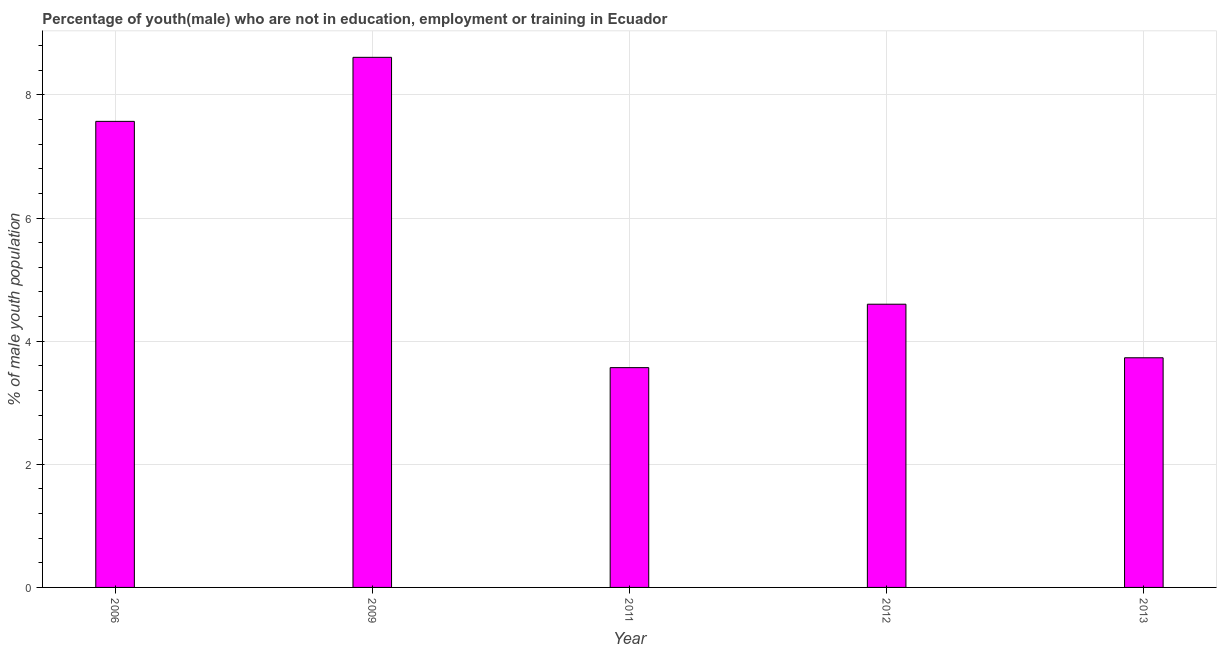Does the graph contain any zero values?
Make the answer very short. No. What is the title of the graph?
Keep it short and to the point. Percentage of youth(male) who are not in education, employment or training in Ecuador. What is the label or title of the X-axis?
Your answer should be compact. Year. What is the label or title of the Y-axis?
Offer a terse response. % of male youth population. What is the unemployed male youth population in 2012?
Your answer should be very brief. 4.6. Across all years, what is the maximum unemployed male youth population?
Provide a succinct answer. 8.61. Across all years, what is the minimum unemployed male youth population?
Ensure brevity in your answer.  3.57. In which year was the unemployed male youth population maximum?
Provide a succinct answer. 2009. What is the sum of the unemployed male youth population?
Your response must be concise. 28.08. What is the difference between the unemployed male youth population in 2011 and 2012?
Provide a succinct answer. -1.03. What is the average unemployed male youth population per year?
Your answer should be very brief. 5.62. What is the median unemployed male youth population?
Offer a terse response. 4.6. In how many years, is the unemployed male youth population greater than 5.6 %?
Provide a succinct answer. 2. Do a majority of the years between 2011 and 2012 (inclusive) have unemployed male youth population greater than 5.2 %?
Ensure brevity in your answer.  No. What is the ratio of the unemployed male youth population in 2006 to that in 2012?
Your answer should be compact. 1.65. What is the difference between the highest and the second highest unemployed male youth population?
Offer a very short reply. 1.04. What is the difference between the highest and the lowest unemployed male youth population?
Offer a terse response. 5.04. Are all the bars in the graph horizontal?
Your response must be concise. No. What is the % of male youth population in 2006?
Your response must be concise. 7.57. What is the % of male youth population in 2009?
Keep it short and to the point. 8.61. What is the % of male youth population in 2011?
Provide a succinct answer. 3.57. What is the % of male youth population of 2012?
Your answer should be very brief. 4.6. What is the % of male youth population of 2013?
Your answer should be very brief. 3.73. What is the difference between the % of male youth population in 2006 and 2009?
Ensure brevity in your answer.  -1.04. What is the difference between the % of male youth population in 2006 and 2012?
Your answer should be compact. 2.97. What is the difference between the % of male youth population in 2006 and 2013?
Provide a short and direct response. 3.84. What is the difference between the % of male youth population in 2009 and 2011?
Your response must be concise. 5.04. What is the difference between the % of male youth population in 2009 and 2012?
Offer a very short reply. 4.01. What is the difference between the % of male youth population in 2009 and 2013?
Your answer should be compact. 4.88. What is the difference between the % of male youth population in 2011 and 2012?
Provide a short and direct response. -1.03. What is the difference between the % of male youth population in 2011 and 2013?
Offer a very short reply. -0.16. What is the difference between the % of male youth population in 2012 and 2013?
Your answer should be compact. 0.87. What is the ratio of the % of male youth population in 2006 to that in 2009?
Your answer should be compact. 0.88. What is the ratio of the % of male youth population in 2006 to that in 2011?
Your answer should be very brief. 2.12. What is the ratio of the % of male youth population in 2006 to that in 2012?
Offer a very short reply. 1.65. What is the ratio of the % of male youth population in 2006 to that in 2013?
Provide a succinct answer. 2.03. What is the ratio of the % of male youth population in 2009 to that in 2011?
Your answer should be very brief. 2.41. What is the ratio of the % of male youth population in 2009 to that in 2012?
Keep it short and to the point. 1.87. What is the ratio of the % of male youth population in 2009 to that in 2013?
Your answer should be very brief. 2.31. What is the ratio of the % of male youth population in 2011 to that in 2012?
Your answer should be compact. 0.78. What is the ratio of the % of male youth population in 2012 to that in 2013?
Give a very brief answer. 1.23. 